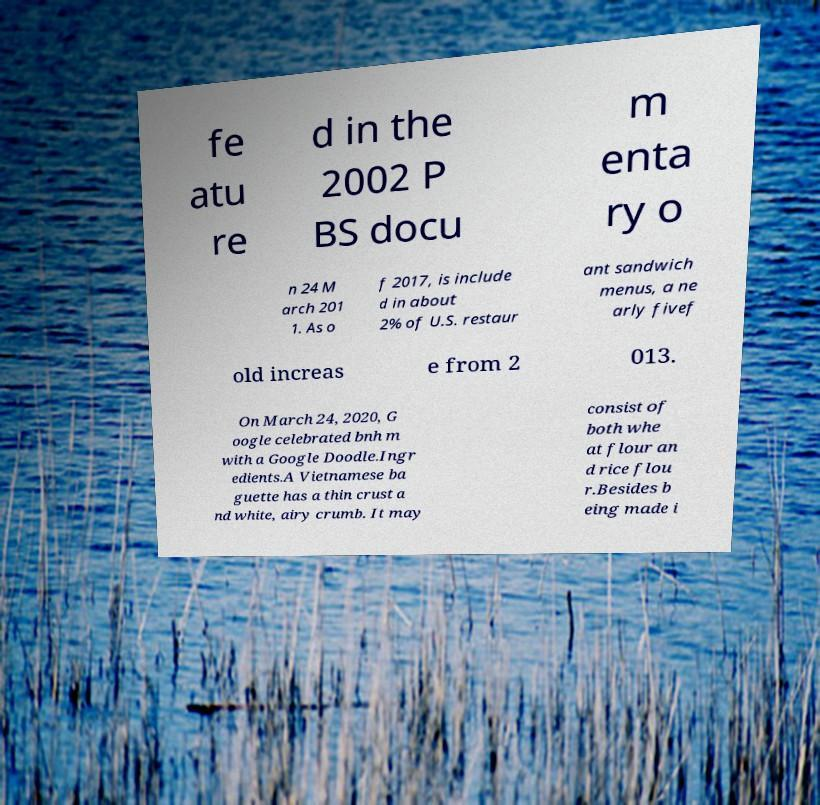Can you read and provide the text displayed in the image?This photo seems to have some interesting text. Can you extract and type it out for me? fe atu re d in the 2002 P BS docu m enta ry o n 24 M arch 201 1. As o f 2017, is include d in about 2% of U.S. restaur ant sandwich menus, a ne arly fivef old increas e from 2 013. On March 24, 2020, G oogle celebrated bnh m with a Google Doodle.Ingr edients.A Vietnamese ba guette has a thin crust a nd white, airy crumb. It may consist of both whe at flour an d rice flou r.Besides b eing made i 